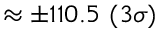Convert formula to latex. <formula><loc_0><loc_0><loc_500><loc_500>\approx \pm 1 1 0 . 5 \ ( 3 \sigma )</formula> 